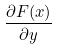<formula> <loc_0><loc_0><loc_500><loc_500>\frac { \partial F ( x ) } { \partial y }</formula> 